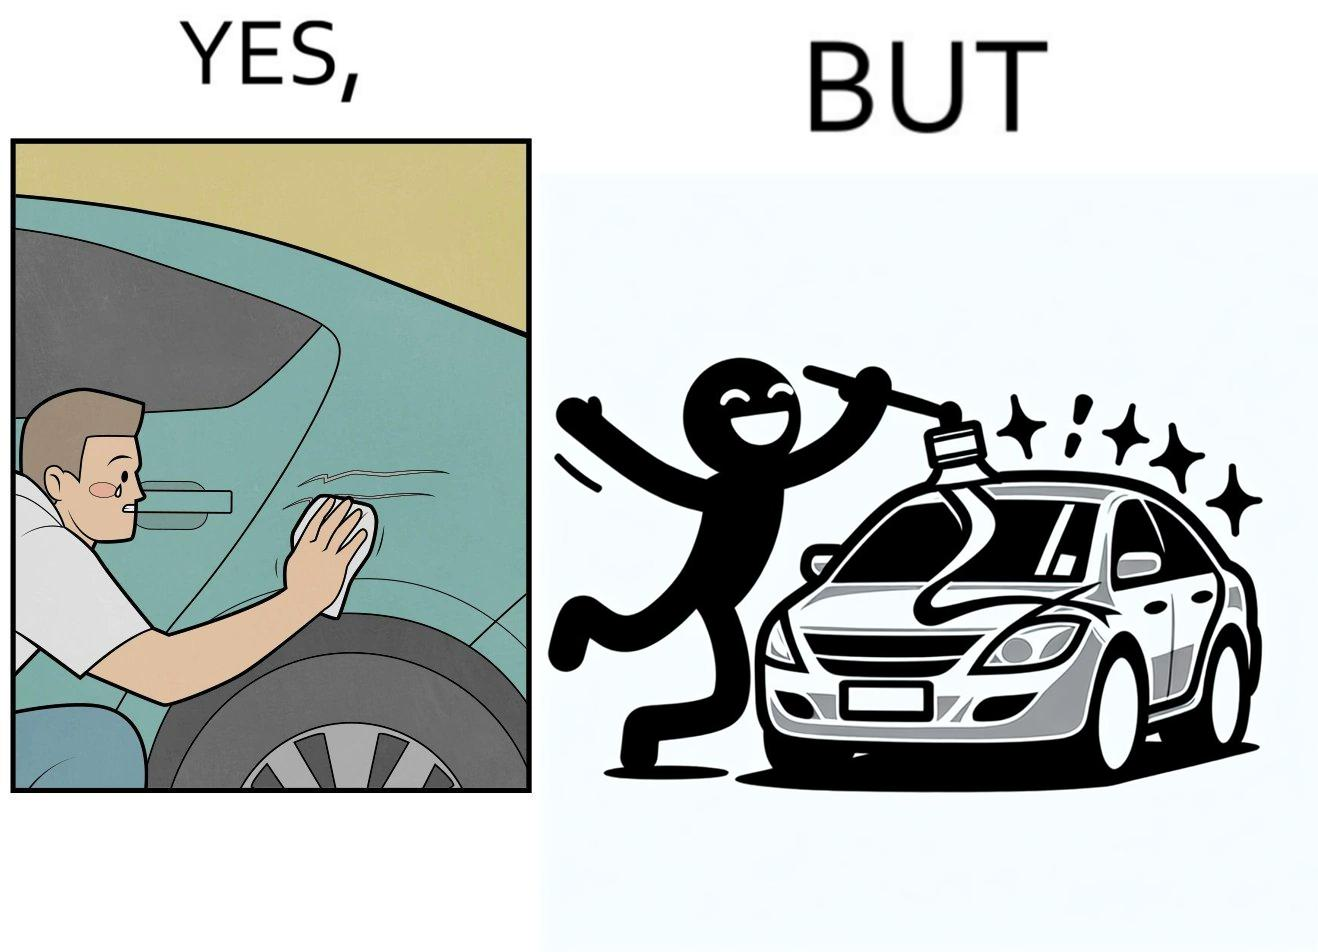What does this image depict? The image is ironic, because the person who cries over the scratches on his car but applies stickers on his car happily which is quite dual nature of the person 